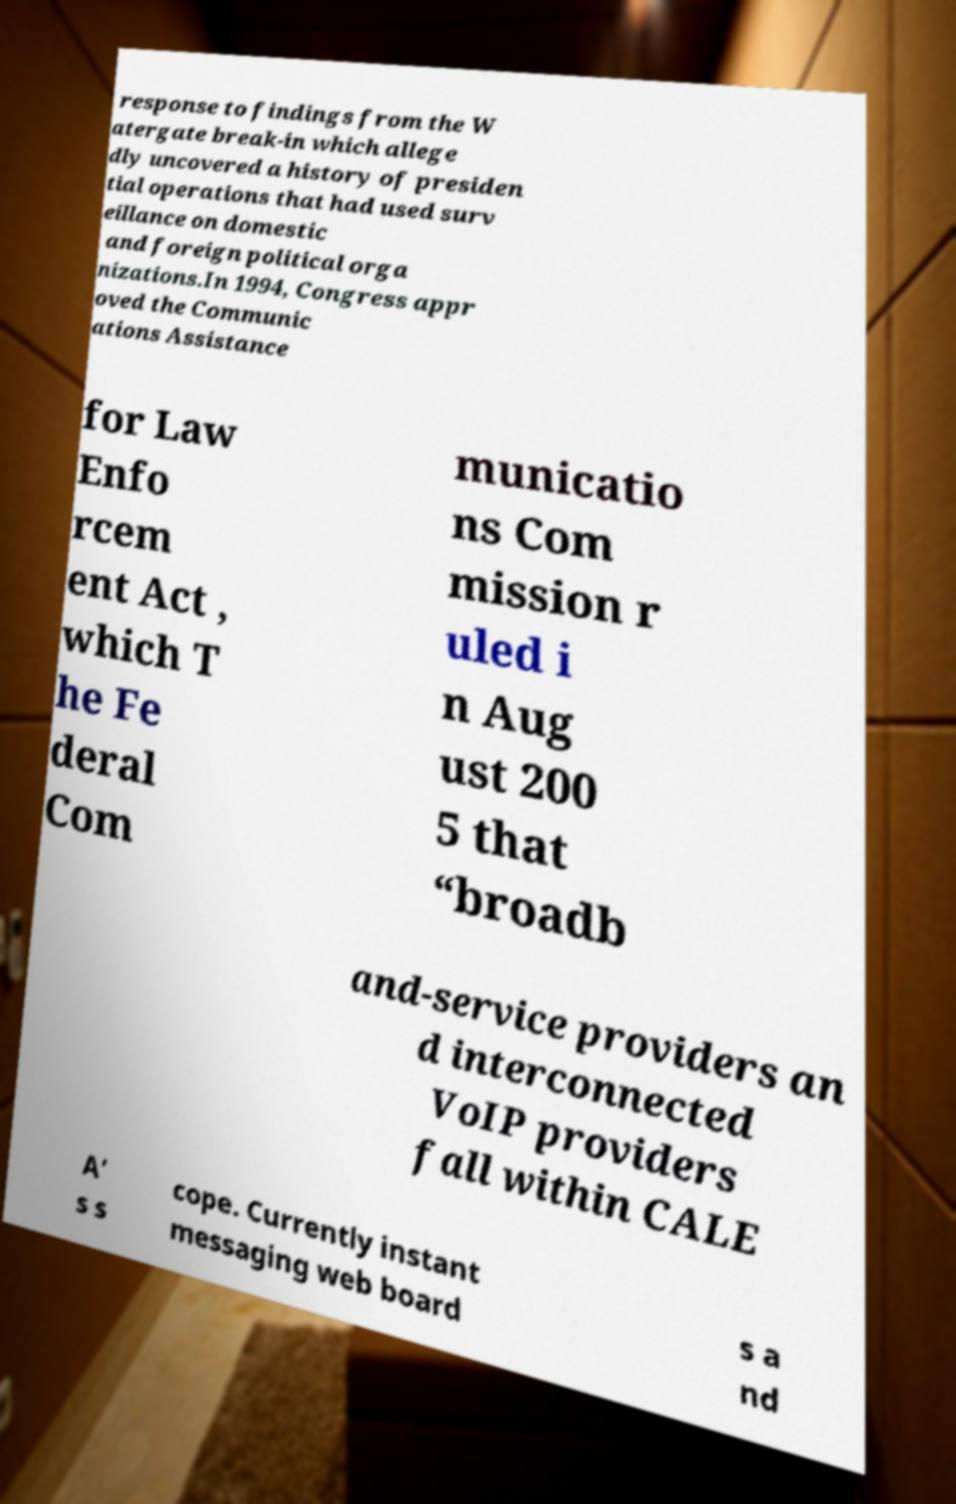I need the written content from this picture converted into text. Can you do that? response to findings from the W atergate break-in which allege dly uncovered a history of presiden tial operations that had used surv eillance on domestic and foreign political orga nizations.In 1994, Congress appr oved the Communic ations Assistance for Law Enfo rcem ent Act , which T he Fe deral Com municatio ns Com mission r uled i n Aug ust 200 5 that “broadb and-service providers an d interconnected VoIP providers fall within CALE A’ s s cope. Currently instant messaging web board s a nd 